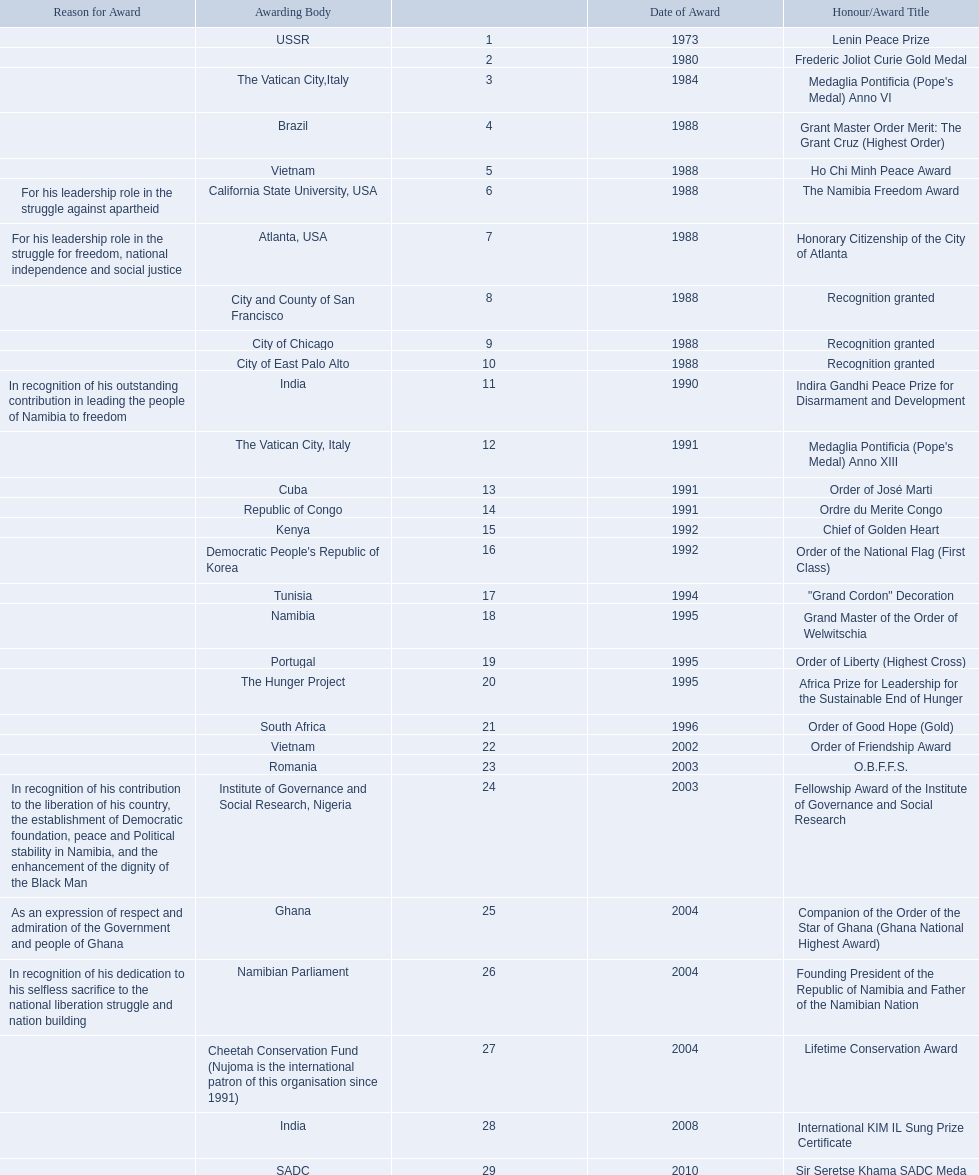Which awarding bodies have recognized sam nujoma? USSR, , The Vatican City,Italy, Brazil, Vietnam, California State University, USA, Atlanta, USA, City and County of San Francisco, City of Chicago, City of East Palo Alto, India, The Vatican City, Italy, Cuba, Republic of Congo, Kenya, Democratic People's Republic of Korea, Tunisia, Namibia, Portugal, The Hunger Project, South Africa, Vietnam, Romania, Institute of Governance and Social Research, Nigeria, Ghana, Namibian Parliament, Cheetah Conservation Fund (Nujoma is the international patron of this organisation since 1991), India, SADC. And what was the title of each award or honour? Lenin Peace Prize, Frederic Joliot Curie Gold Medal, Medaglia Pontificia (Pope's Medal) Anno VI, Grant Master Order Merit: The Grant Cruz (Highest Order), Ho Chi Minh Peace Award, The Namibia Freedom Award, Honorary Citizenship of the City of Atlanta, Recognition granted, Recognition granted, Recognition granted, Indira Gandhi Peace Prize for Disarmament and Development, Medaglia Pontificia (Pope's Medal) Anno XIII, Order of José Marti, Ordre du Merite Congo, Chief of Golden Heart, Order of the National Flag (First Class), "Grand Cordon" Decoration, Grand Master of the Order of Welwitschia, Order of Liberty (Highest Cross), Africa Prize for Leadership for the Sustainable End of Hunger, Order of Good Hope (Gold), Order of Friendship Award, O.B.F.F.S., Fellowship Award of the Institute of Governance and Social Research, Companion of the Order of the Star of Ghana (Ghana National Highest Award), Founding President of the Republic of Namibia and Father of the Namibian Nation, Lifetime Conservation Award, International KIM IL Sung Prize Certificate, Sir Seretse Khama SADC Meda. Of those, which nation awarded him the o.b.f.f.s.? Romania. 